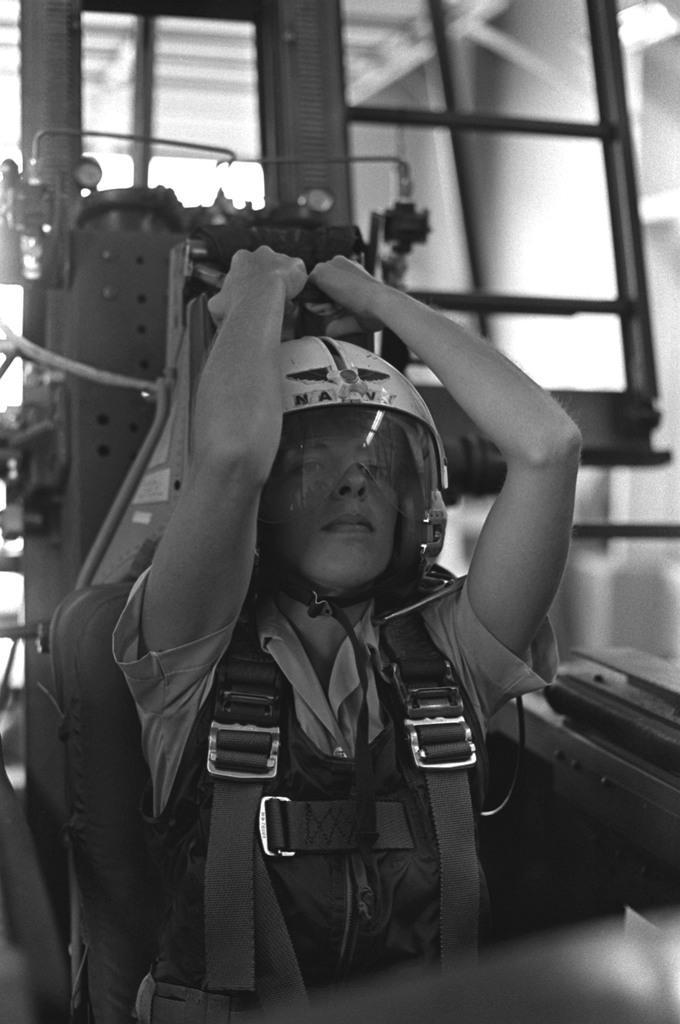Please provide a concise description of this image. Here in this picture we can see a woman sitting over a place, as we can see she is wearing jacket on her and wearing a helmet on her. 